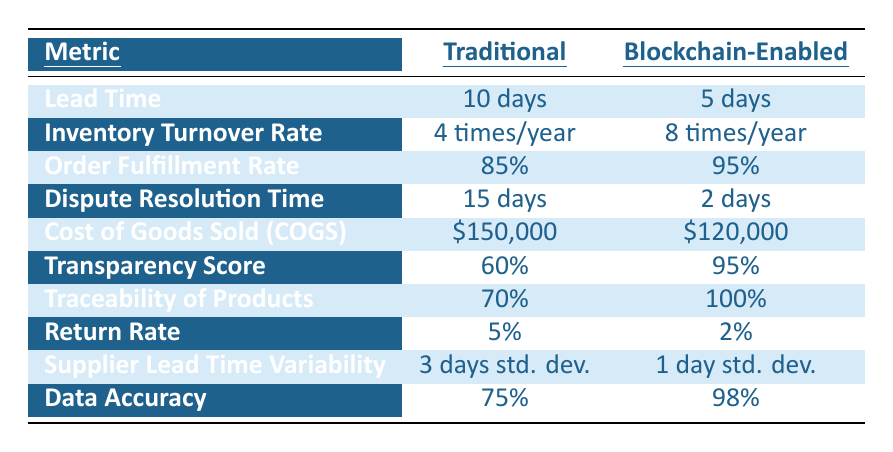What is the Lead Time for the traditional supply chain? The Lead Time for the traditional supply chain is listed directly in the table under the “Traditional” column for the “Lead Time” metric, which is 10 days.
Answer: 10 days What is the Inventory Turnover Rate for the blockchain-enabled supply chain? The Inventory Turnover Rate for the blockchain-enabled supply chain is found in the table under the “Blockchain-Enabled” column for the “Inventory Turnover Rate” metric, which is 8 times/year.
Answer: 8 times/year Which system has a higher Order Fulfillment Rate, traditional or blockchain-enabled? According to the table, the Order Fulfillment Rate for traditional is 85%, while for blockchain-enabled it is 95%. Since 95% is greater than 85%, the blockchain-enabled system has a higher rate.
Answer: Blockchain-enabled How much is saved in Cost of Goods Sold (COGS) when using blockchain-enabled supply chain compared to traditional? The traditional COGS is $150,000 and the blockchain-enabled COGS is $120,000. The savings can be calculated by subtracting $120,000 from $150,000, resulting in a savings of $30,000.
Answer: $30,000 Is the Transparency Score for blockchain-enabled supply chain greater than 80%? The Transparency Score listed in the table for blockchain-enabled supply chain is 95%. Since 95% is greater than 80%, the statement is true.
Answer: Yes What is the percentage difference in the Return Rate between traditional and blockchain-enabled systems? The traditional Return Rate is 5%, and the blockchain-enabled Return Rate is 2%. The difference is calculated by subtracting 2% from 5%, which gives a difference of 3%. Then we can express it as a percentage by considering the traditional value: (3% / 5%) * 100 = 60%.
Answer: 60% Which metric shows the largest improvement when moving from traditional to blockchain-enabled supply chain? To find the largest improvement, compare the differences in values for all metrics listed. The greatest improvement is in Dispute Resolution Time, which decreased from 15 days to 2 days, showing an improvement of 13 days.
Answer: Dispute Resolution Time If we consider Data Accuracy in both systems, which has a larger percentage increase from traditional to blockchain-enabled? The Data Accuracy for traditional is 75% and for blockchain-enabled it is 98%. The increase is calculated as 98% - 75% = 23%. To express this as a percentage increase of the traditional value: (23% / 75%) * 100 = 30.67%.
Answer: 30.67% What is the standard deviation difference in Supplier Lead Time Variability between the two systems? The traditional standard deviation for Supplier Lead Time Variability is 3 days and the blockchain-enabled standard deviation is 1 day. The difference between these values is 3 days - 1 day = 2 days.
Answer: 2 days How does the Traceability of Products compare between traditional and blockchain-enabled systems? The Traceability of Products for the traditional system is 70%, while for the blockchain-enabled system it is 100%. The blockchain-enabled system has improved traceability, indicating a direct increase of 30%.
Answer: Improved by 30% 